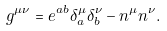<formula> <loc_0><loc_0><loc_500><loc_500>g ^ { \mu \nu } = e ^ { a b } \delta ^ { \mu } _ { a } \delta ^ { \nu } _ { b } - n ^ { \mu } n ^ { \nu } .</formula> 